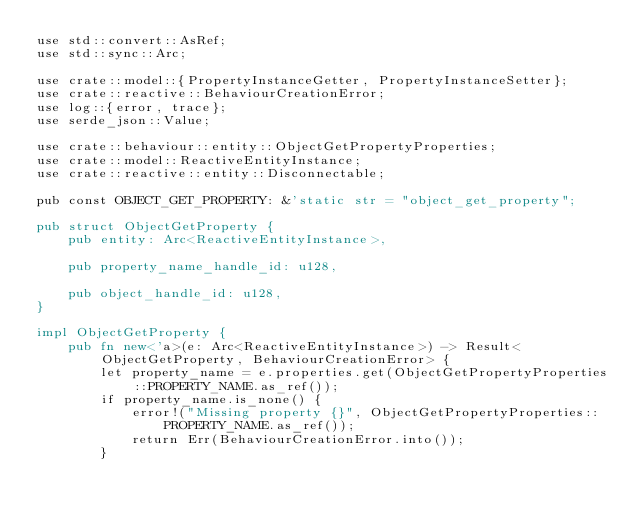<code> <loc_0><loc_0><loc_500><loc_500><_Rust_>use std::convert::AsRef;
use std::sync::Arc;

use crate::model::{PropertyInstanceGetter, PropertyInstanceSetter};
use crate::reactive::BehaviourCreationError;
use log::{error, trace};
use serde_json::Value;

use crate::behaviour::entity::ObjectGetPropertyProperties;
use crate::model::ReactiveEntityInstance;
use crate::reactive::entity::Disconnectable;

pub const OBJECT_GET_PROPERTY: &'static str = "object_get_property";

pub struct ObjectGetProperty {
    pub entity: Arc<ReactiveEntityInstance>,

    pub property_name_handle_id: u128,

    pub object_handle_id: u128,
}

impl ObjectGetProperty {
    pub fn new<'a>(e: Arc<ReactiveEntityInstance>) -> Result<ObjectGetProperty, BehaviourCreationError> {
        let property_name = e.properties.get(ObjectGetPropertyProperties::PROPERTY_NAME.as_ref());
        if property_name.is_none() {
            error!("Missing property {}", ObjectGetPropertyProperties::PROPERTY_NAME.as_ref());
            return Err(BehaviourCreationError.into());
        }</code> 